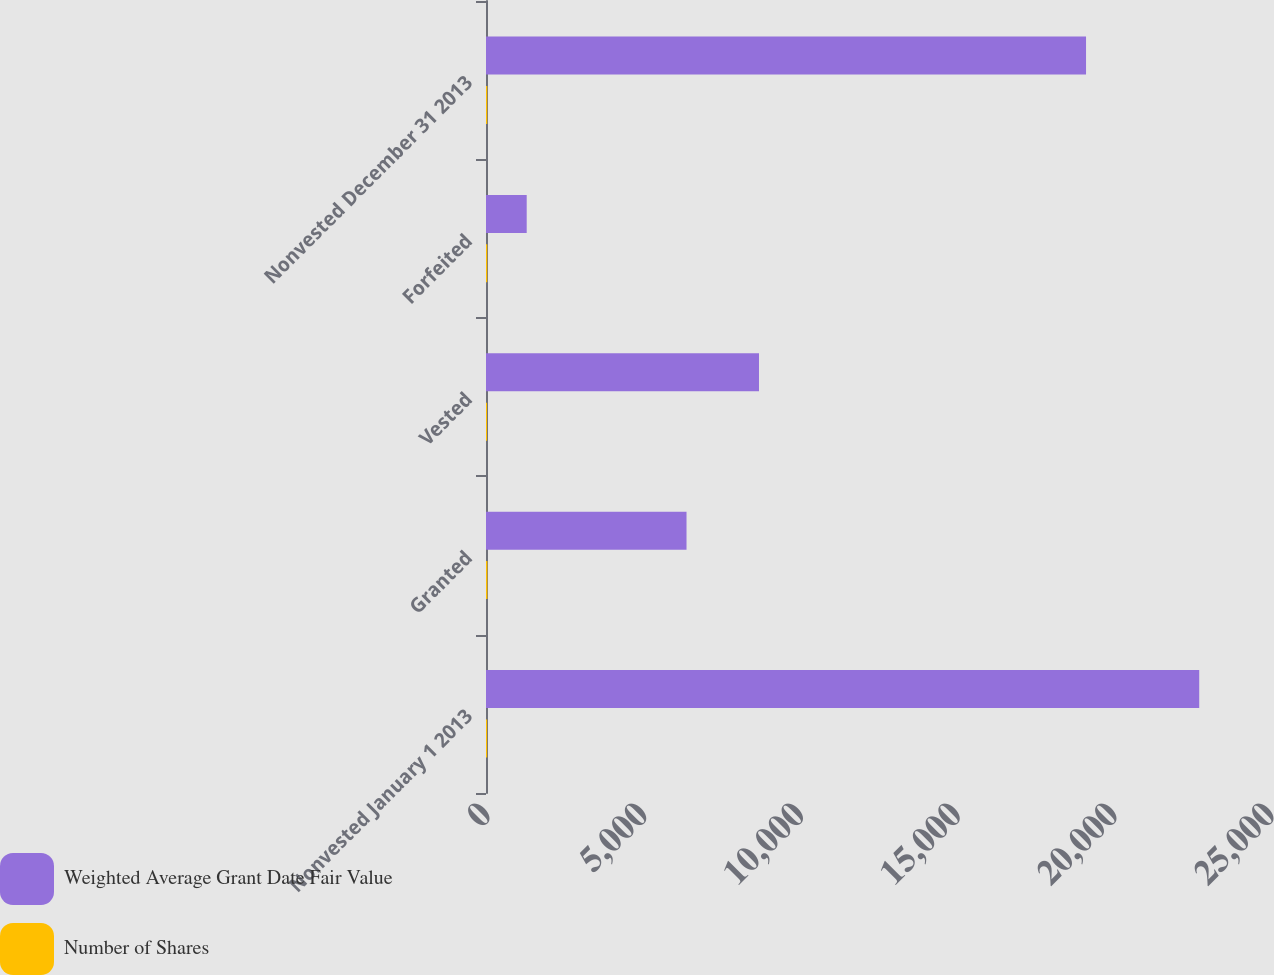Convert chart to OTSL. <chart><loc_0><loc_0><loc_500><loc_500><stacked_bar_chart><ecel><fcel>Nonvested January 1 2013<fcel>Granted<fcel>Vested<fcel>Forfeited<fcel>Nonvested December 31 2013<nl><fcel>Weighted Average Grant Date Fair Value<fcel>22743<fcel>6394<fcel>8705<fcel>1298<fcel>19134<nl><fcel>Number of Shares<fcel>36.38<fcel>45.04<fcel>34.1<fcel>40.02<fcel>40.07<nl></chart> 